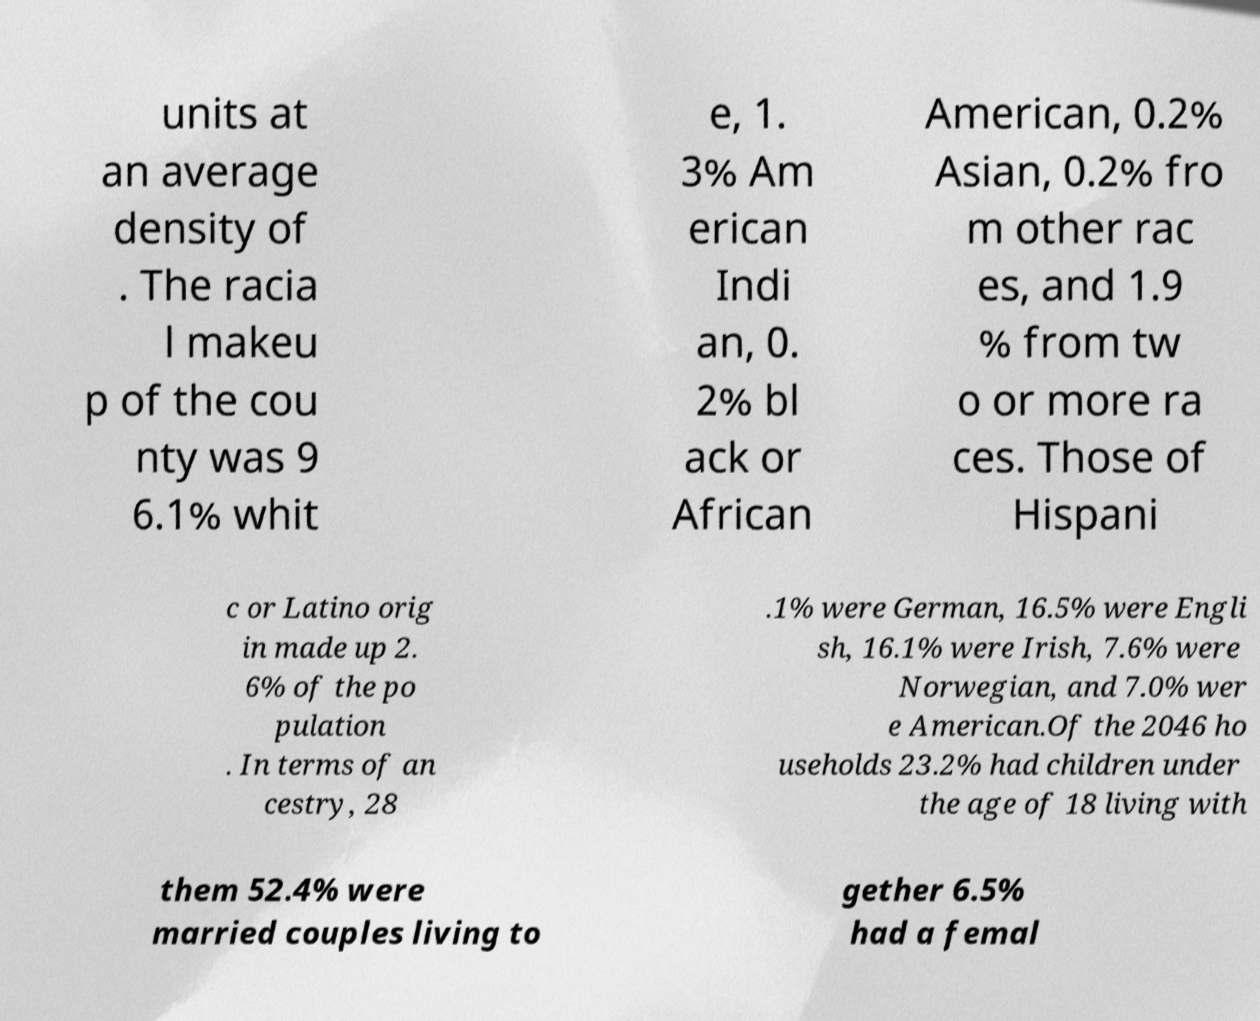Please identify and transcribe the text found in this image. units at an average density of . The racia l makeu p of the cou nty was 9 6.1% whit e, 1. 3% Am erican Indi an, 0. 2% bl ack or African American, 0.2% Asian, 0.2% fro m other rac es, and 1.9 % from tw o or more ra ces. Those of Hispani c or Latino orig in made up 2. 6% of the po pulation . In terms of an cestry, 28 .1% were German, 16.5% were Engli sh, 16.1% were Irish, 7.6% were Norwegian, and 7.0% wer e American.Of the 2046 ho useholds 23.2% had children under the age of 18 living with them 52.4% were married couples living to gether 6.5% had a femal 